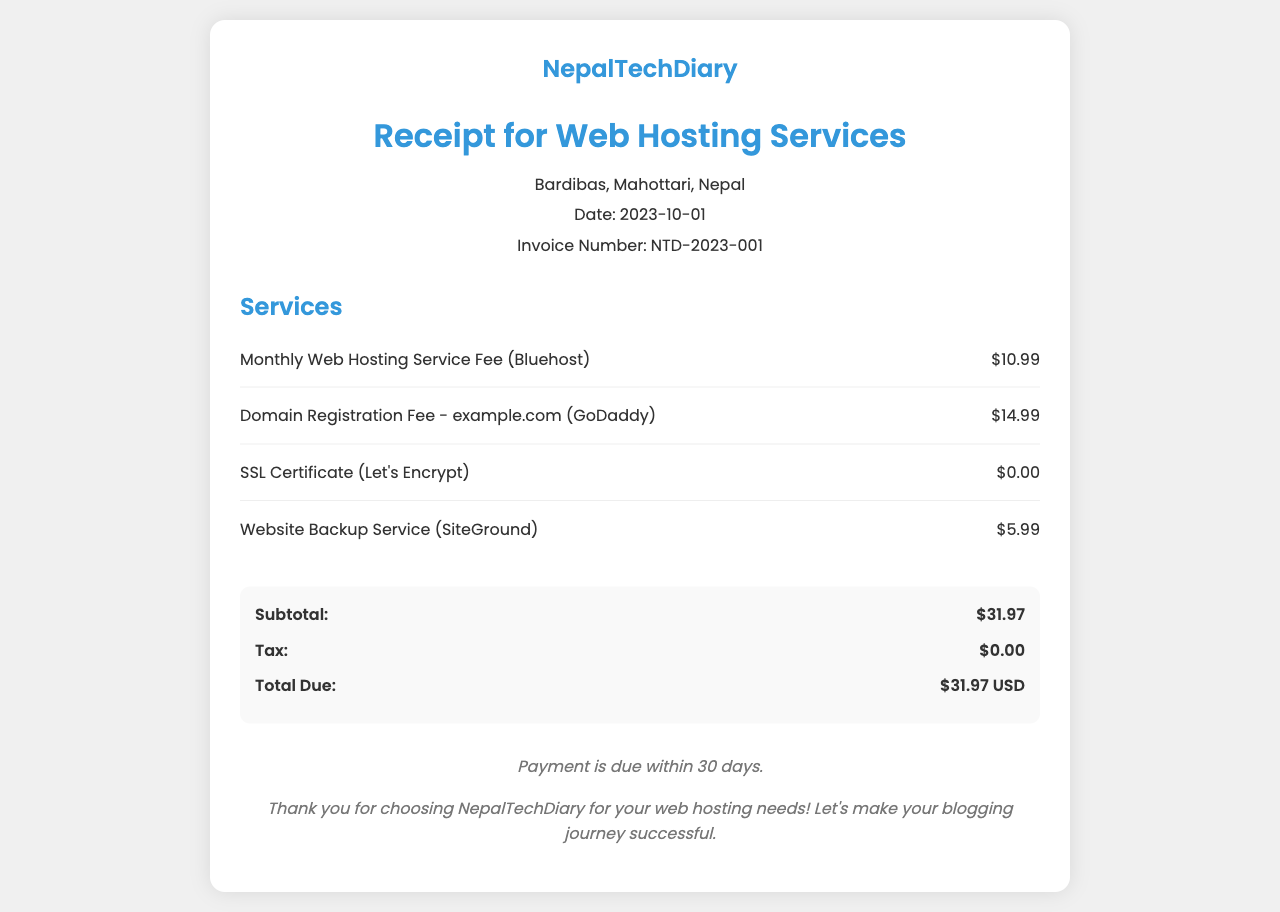what is the invoice number? The invoice number is referenced in the document as NTD-2023-001.
Answer: NTD-2023-001 what is the total due amount? The total due amount is located in the section under Total Due, which is $31.97.
Answer: $31.97 USD when was this receipt issued? The date of the receipt is mentioned in the header section, noted as 2023-10-01.
Answer: 2023-10-01 who is the service provider for web hosting? The provider for the monthly web hosting service is specified as Bluehost.
Answer: Bluehost what is the subtotal before tax? The subtotal is listed as the sum of services before tax, which is $31.97.
Answer: $31.97 what type of certificate is included for free? The document mentions an SSL Certificate from Let's Encrypt as free of charge.
Answer: Let's Encrypt what is the location of NepalTechDiary? The location is indicated as Bardibas, Mahottari, Nepal.
Answer: Bardibas, Mahottari, Nepal what is the domain registration fee? The fee for domain registration for example.com is mentioned as $14.99.
Answer: $14.99 